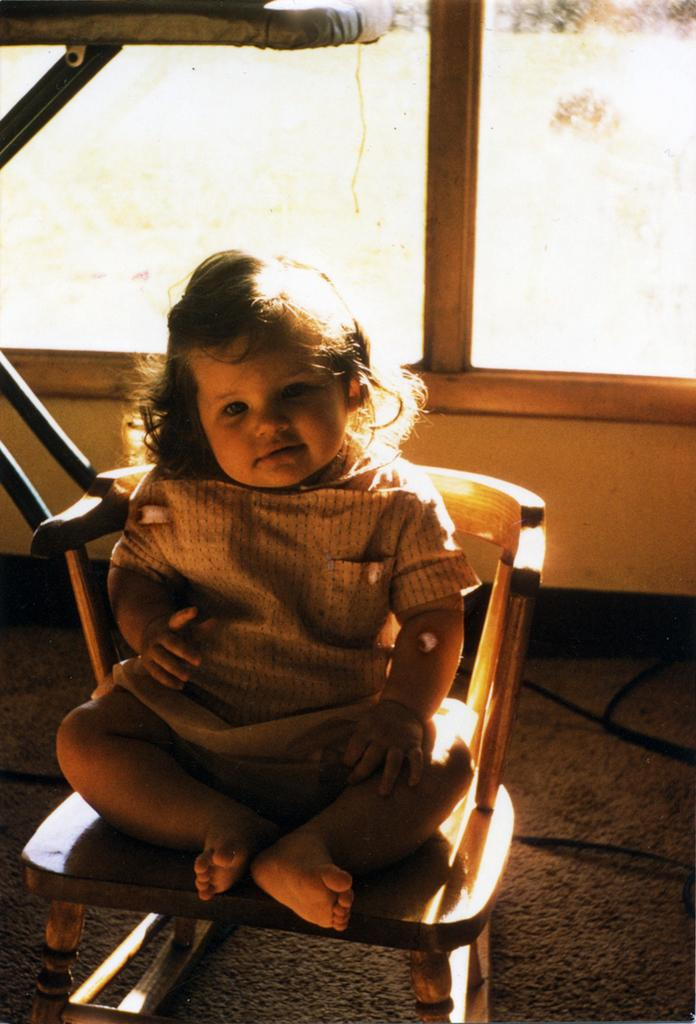What is the main subject of the image? The main subject of the image is a kid. What is the kid doing in the image? The kid is sitting on a chair. What part of the room can be seen in the image? The floor is visible in the image. What is the weight of the blade that the kid is holding in the image? There is no blade present in the image, so it is not possible to determine its weight. 